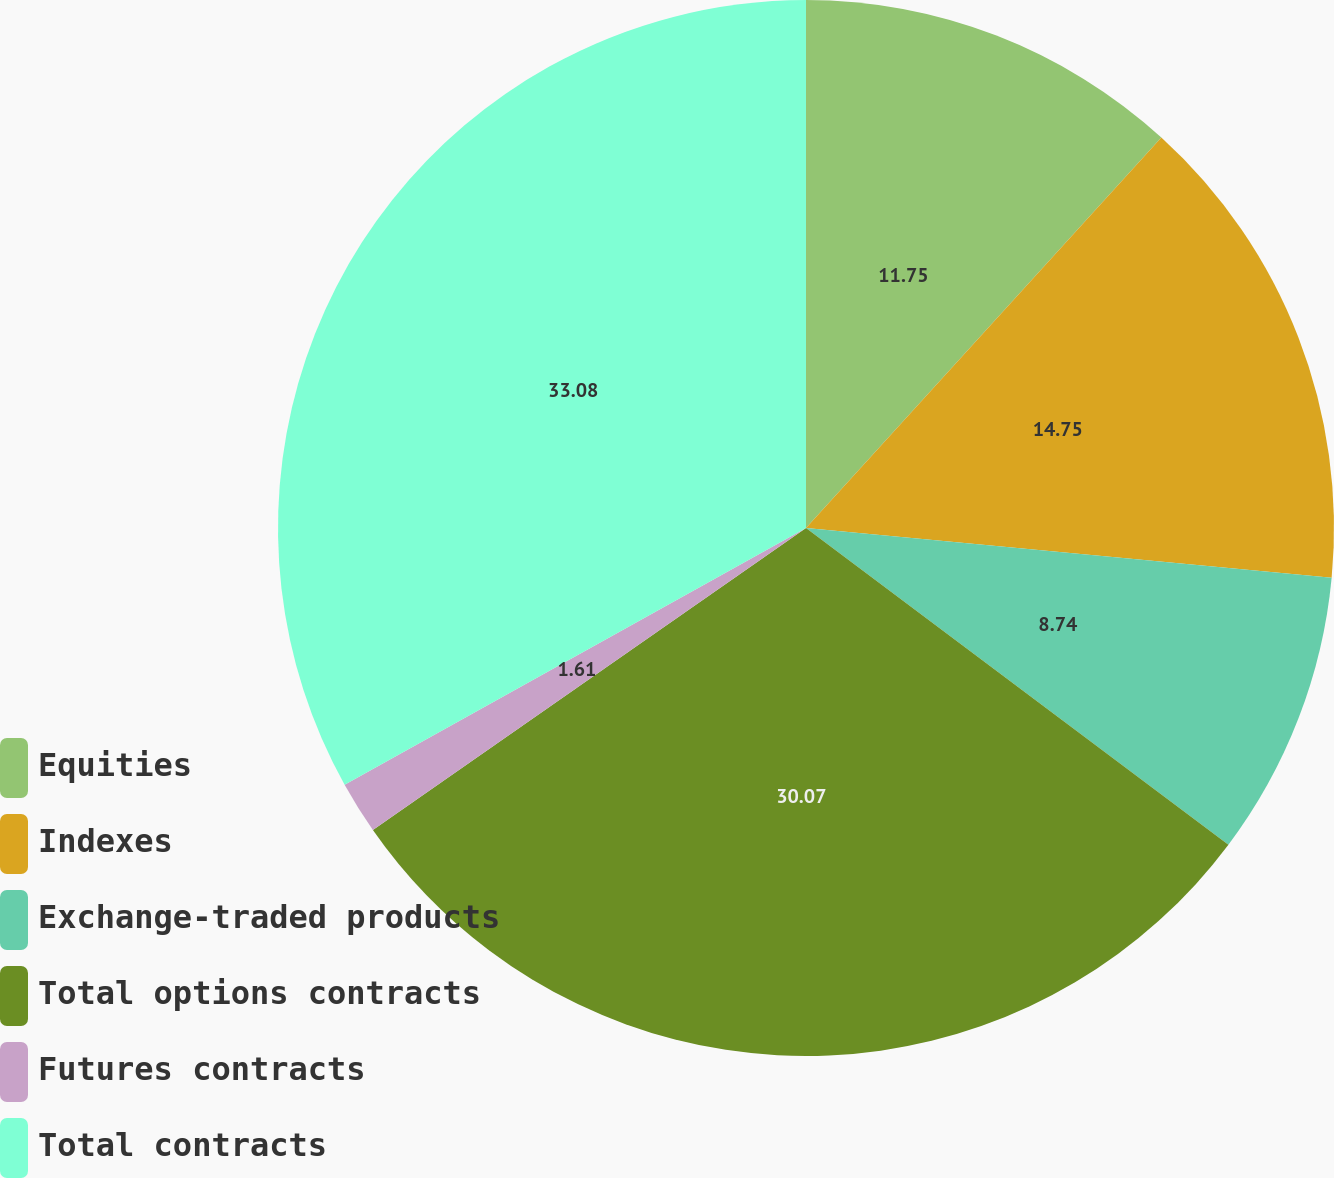Convert chart to OTSL. <chart><loc_0><loc_0><loc_500><loc_500><pie_chart><fcel>Equities<fcel>Indexes<fcel>Exchange-traded products<fcel>Total options contracts<fcel>Futures contracts<fcel>Total contracts<nl><fcel>11.75%<fcel>14.75%<fcel>8.74%<fcel>30.07%<fcel>1.61%<fcel>33.08%<nl></chart> 